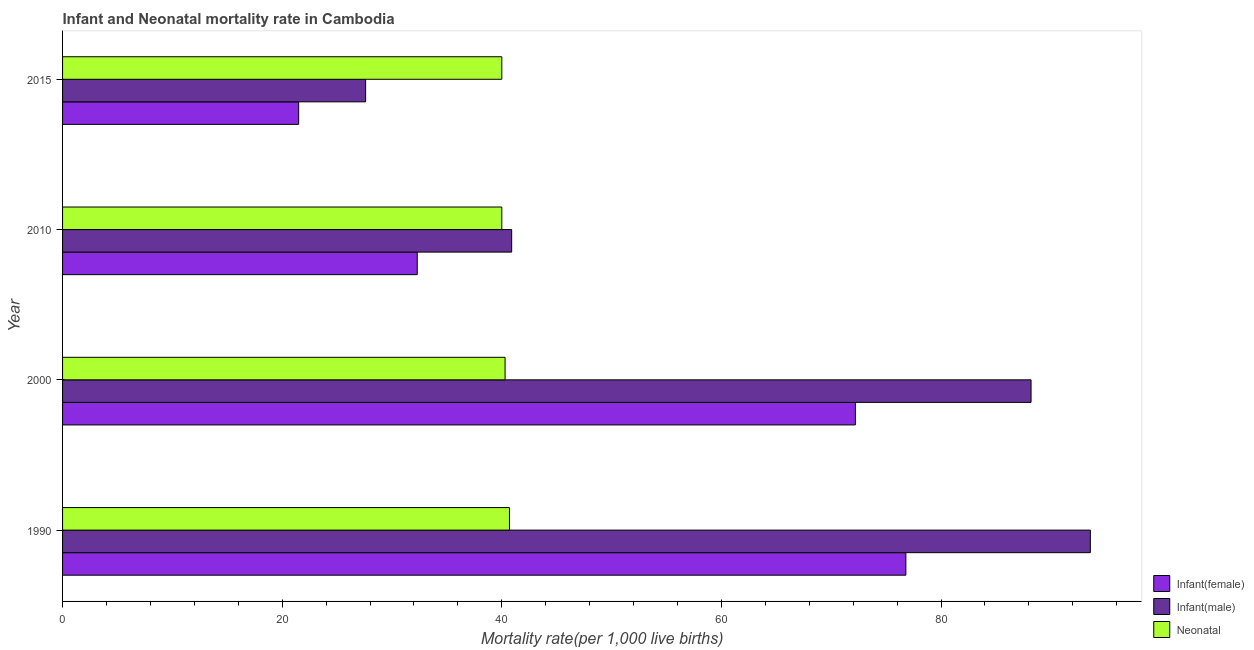What is the label of the 3rd group of bars from the top?
Your response must be concise. 2000. In how many cases, is the number of bars for a given year not equal to the number of legend labels?
Offer a very short reply. 0. What is the infant mortality rate(female) in 2015?
Give a very brief answer. 21.5. Across all years, what is the maximum infant mortality rate(female)?
Give a very brief answer. 76.8. Across all years, what is the minimum infant mortality rate(female)?
Give a very brief answer. 21.5. In which year was the infant mortality rate(female) minimum?
Your response must be concise. 2015. What is the total infant mortality rate(male) in the graph?
Provide a succinct answer. 250.3. What is the difference between the infant mortality rate(male) in 1990 and that in 2010?
Offer a very short reply. 52.7. What is the difference between the neonatal mortality rate in 2010 and the infant mortality rate(female) in 2015?
Your answer should be compact. 18.5. What is the average infant mortality rate(female) per year?
Your response must be concise. 50.7. In the year 2010, what is the difference between the neonatal mortality rate and infant mortality rate(female)?
Offer a terse response. 7.7. What is the ratio of the infant mortality rate(female) in 1990 to that in 2015?
Provide a short and direct response. 3.57. Is the infant mortality rate(female) in 2000 less than that in 2015?
Provide a succinct answer. No. What is the difference between the highest and the second highest neonatal mortality rate?
Provide a short and direct response. 0.4. What is the difference between the highest and the lowest infant mortality rate(male)?
Provide a short and direct response. 66. Is the sum of the infant mortality rate(female) in 2000 and 2010 greater than the maximum neonatal mortality rate across all years?
Make the answer very short. Yes. What does the 2nd bar from the top in 1990 represents?
Offer a very short reply. Infant(male). What does the 2nd bar from the bottom in 2015 represents?
Give a very brief answer. Infant(male). Is it the case that in every year, the sum of the infant mortality rate(female) and infant mortality rate(male) is greater than the neonatal mortality rate?
Make the answer very short. Yes. How many bars are there?
Offer a very short reply. 12. Are all the bars in the graph horizontal?
Your answer should be very brief. Yes. Are the values on the major ticks of X-axis written in scientific E-notation?
Provide a short and direct response. No. Does the graph contain any zero values?
Give a very brief answer. No. How many legend labels are there?
Offer a very short reply. 3. How are the legend labels stacked?
Give a very brief answer. Vertical. What is the title of the graph?
Your answer should be very brief. Infant and Neonatal mortality rate in Cambodia. Does "Argument" appear as one of the legend labels in the graph?
Make the answer very short. No. What is the label or title of the X-axis?
Your answer should be very brief. Mortality rate(per 1,0 live births). What is the label or title of the Y-axis?
Offer a very short reply. Year. What is the Mortality rate(per 1,000 live births) in Infant(female) in 1990?
Provide a succinct answer. 76.8. What is the Mortality rate(per 1,000 live births) of Infant(male) in 1990?
Offer a very short reply. 93.6. What is the Mortality rate(per 1,000 live births) in Neonatal  in 1990?
Make the answer very short. 40.7. What is the Mortality rate(per 1,000 live births) of Infant(female) in 2000?
Your answer should be very brief. 72.2. What is the Mortality rate(per 1,000 live births) in Infant(male) in 2000?
Offer a terse response. 88.2. What is the Mortality rate(per 1,000 live births) of Neonatal  in 2000?
Make the answer very short. 40.3. What is the Mortality rate(per 1,000 live births) of Infant(female) in 2010?
Your answer should be compact. 32.3. What is the Mortality rate(per 1,000 live births) in Infant(male) in 2010?
Your response must be concise. 40.9. What is the Mortality rate(per 1,000 live births) in Neonatal  in 2010?
Your answer should be very brief. 40. What is the Mortality rate(per 1,000 live births) of Infant(male) in 2015?
Keep it short and to the point. 27.6. What is the Mortality rate(per 1,000 live births) of Neonatal  in 2015?
Provide a short and direct response. 40. Across all years, what is the maximum Mortality rate(per 1,000 live births) in Infant(female)?
Provide a short and direct response. 76.8. Across all years, what is the maximum Mortality rate(per 1,000 live births) in Infant(male)?
Offer a very short reply. 93.6. Across all years, what is the maximum Mortality rate(per 1,000 live births) in Neonatal ?
Your answer should be very brief. 40.7. Across all years, what is the minimum Mortality rate(per 1,000 live births) of Infant(female)?
Make the answer very short. 21.5. Across all years, what is the minimum Mortality rate(per 1,000 live births) of Infant(male)?
Give a very brief answer. 27.6. Across all years, what is the minimum Mortality rate(per 1,000 live births) in Neonatal ?
Ensure brevity in your answer.  40. What is the total Mortality rate(per 1,000 live births) of Infant(female) in the graph?
Make the answer very short. 202.8. What is the total Mortality rate(per 1,000 live births) in Infant(male) in the graph?
Offer a very short reply. 250.3. What is the total Mortality rate(per 1,000 live births) in Neonatal  in the graph?
Give a very brief answer. 161. What is the difference between the Mortality rate(per 1,000 live births) of Infant(male) in 1990 and that in 2000?
Your answer should be compact. 5.4. What is the difference between the Mortality rate(per 1,000 live births) in Infant(female) in 1990 and that in 2010?
Your response must be concise. 44.5. What is the difference between the Mortality rate(per 1,000 live births) in Infant(male) in 1990 and that in 2010?
Ensure brevity in your answer.  52.7. What is the difference between the Mortality rate(per 1,000 live births) in Neonatal  in 1990 and that in 2010?
Provide a succinct answer. 0.7. What is the difference between the Mortality rate(per 1,000 live births) in Infant(female) in 1990 and that in 2015?
Provide a short and direct response. 55.3. What is the difference between the Mortality rate(per 1,000 live births) in Infant(female) in 2000 and that in 2010?
Make the answer very short. 39.9. What is the difference between the Mortality rate(per 1,000 live births) in Infant(male) in 2000 and that in 2010?
Your answer should be compact. 47.3. What is the difference between the Mortality rate(per 1,000 live births) in Neonatal  in 2000 and that in 2010?
Provide a succinct answer. 0.3. What is the difference between the Mortality rate(per 1,000 live births) of Infant(female) in 2000 and that in 2015?
Provide a succinct answer. 50.7. What is the difference between the Mortality rate(per 1,000 live births) in Infant(male) in 2000 and that in 2015?
Your response must be concise. 60.6. What is the difference between the Mortality rate(per 1,000 live births) of Infant(female) in 2010 and that in 2015?
Your answer should be very brief. 10.8. What is the difference between the Mortality rate(per 1,000 live births) of Infant(male) in 2010 and that in 2015?
Give a very brief answer. 13.3. What is the difference between the Mortality rate(per 1,000 live births) of Neonatal  in 2010 and that in 2015?
Provide a succinct answer. 0. What is the difference between the Mortality rate(per 1,000 live births) in Infant(female) in 1990 and the Mortality rate(per 1,000 live births) in Neonatal  in 2000?
Offer a very short reply. 36.5. What is the difference between the Mortality rate(per 1,000 live births) in Infant(male) in 1990 and the Mortality rate(per 1,000 live births) in Neonatal  in 2000?
Provide a short and direct response. 53.3. What is the difference between the Mortality rate(per 1,000 live births) in Infant(female) in 1990 and the Mortality rate(per 1,000 live births) in Infant(male) in 2010?
Your response must be concise. 35.9. What is the difference between the Mortality rate(per 1,000 live births) of Infant(female) in 1990 and the Mortality rate(per 1,000 live births) of Neonatal  in 2010?
Your response must be concise. 36.8. What is the difference between the Mortality rate(per 1,000 live births) in Infant(male) in 1990 and the Mortality rate(per 1,000 live births) in Neonatal  in 2010?
Provide a succinct answer. 53.6. What is the difference between the Mortality rate(per 1,000 live births) in Infant(female) in 1990 and the Mortality rate(per 1,000 live births) in Infant(male) in 2015?
Your response must be concise. 49.2. What is the difference between the Mortality rate(per 1,000 live births) in Infant(female) in 1990 and the Mortality rate(per 1,000 live births) in Neonatal  in 2015?
Your answer should be very brief. 36.8. What is the difference between the Mortality rate(per 1,000 live births) of Infant(male) in 1990 and the Mortality rate(per 1,000 live births) of Neonatal  in 2015?
Offer a very short reply. 53.6. What is the difference between the Mortality rate(per 1,000 live births) in Infant(female) in 2000 and the Mortality rate(per 1,000 live births) in Infant(male) in 2010?
Your response must be concise. 31.3. What is the difference between the Mortality rate(per 1,000 live births) of Infant(female) in 2000 and the Mortality rate(per 1,000 live births) of Neonatal  in 2010?
Offer a terse response. 32.2. What is the difference between the Mortality rate(per 1,000 live births) in Infant(male) in 2000 and the Mortality rate(per 1,000 live births) in Neonatal  in 2010?
Give a very brief answer. 48.2. What is the difference between the Mortality rate(per 1,000 live births) of Infant(female) in 2000 and the Mortality rate(per 1,000 live births) of Infant(male) in 2015?
Give a very brief answer. 44.6. What is the difference between the Mortality rate(per 1,000 live births) in Infant(female) in 2000 and the Mortality rate(per 1,000 live births) in Neonatal  in 2015?
Provide a short and direct response. 32.2. What is the difference between the Mortality rate(per 1,000 live births) in Infant(male) in 2000 and the Mortality rate(per 1,000 live births) in Neonatal  in 2015?
Offer a terse response. 48.2. What is the difference between the Mortality rate(per 1,000 live births) in Infant(female) in 2010 and the Mortality rate(per 1,000 live births) in Infant(male) in 2015?
Provide a succinct answer. 4.7. What is the difference between the Mortality rate(per 1,000 live births) of Infant(male) in 2010 and the Mortality rate(per 1,000 live births) of Neonatal  in 2015?
Your answer should be compact. 0.9. What is the average Mortality rate(per 1,000 live births) in Infant(female) per year?
Provide a short and direct response. 50.7. What is the average Mortality rate(per 1,000 live births) of Infant(male) per year?
Offer a very short reply. 62.58. What is the average Mortality rate(per 1,000 live births) in Neonatal  per year?
Your answer should be compact. 40.25. In the year 1990, what is the difference between the Mortality rate(per 1,000 live births) of Infant(female) and Mortality rate(per 1,000 live births) of Infant(male)?
Your answer should be compact. -16.8. In the year 1990, what is the difference between the Mortality rate(per 1,000 live births) of Infant(female) and Mortality rate(per 1,000 live births) of Neonatal ?
Your response must be concise. 36.1. In the year 1990, what is the difference between the Mortality rate(per 1,000 live births) in Infant(male) and Mortality rate(per 1,000 live births) in Neonatal ?
Make the answer very short. 52.9. In the year 2000, what is the difference between the Mortality rate(per 1,000 live births) in Infant(female) and Mortality rate(per 1,000 live births) in Infant(male)?
Give a very brief answer. -16. In the year 2000, what is the difference between the Mortality rate(per 1,000 live births) of Infant(female) and Mortality rate(per 1,000 live births) of Neonatal ?
Ensure brevity in your answer.  31.9. In the year 2000, what is the difference between the Mortality rate(per 1,000 live births) of Infant(male) and Mortality rate(per 1,000 live births) of Neonatal ?
Provide a short and direct response. 47.9. In the year 2010, what is the difference between the Mortality rate(per 1,000 live births) of Infant(female) and Mortality rate(per 1,000 live births) of Infant(male)?
Offer a very short reply. -8.6. In the year 2010, what is the difference between the Mortality rate(per 1,000 live births) in Infant(female) and Mortality rate(per 1,000 live births) in Neonatal ?
Make the answer very short. -7.7. In the year 2015, what is the difference between the Mortality rate(per 1,000 live births) in Infant(female) and Mortality rate(per 1,000 live births) in Infant(male)?
Your answer should be compact. -6.1. In the year 2015, what is the difference between the Mortality rate(per 1,000 live births) of Infant(female) and Mortality rate(per 1,000 live births) of Neonatal ?
Ensure brevity in your answer.  -18.5. What is the ratio of the Mortality rate(per 1,000 live births) of Infant(female) in 1990 to that in 2000?
Provide a succinct answer. 1.06. What is the ratio of the Mortality rate(per 1,000 live births) in Infant(male) in 1990 to that in 2000?
Offer a terse response. 1.06. What is the ratio of the Mortality rate(per 1,000 live births) of Neonatal  in 1990 to that in 2000?
Give a very brief answer. 1.01. What is the ratio of the Mortality rate(per 1,000 live births) in Infant(female) in 1990 to that in 2010?
Keep it short and to the point. 2.38. What is the ratio of the Mortality rate(per 1,000 live births) of Infant(male) in 1990 to that in 2010?
Your answer should be compact. 2.29. What is the ratio of the Mortality rate(per 1,000 live births) in Neonatal  in 1990 to that in 2010?
Make the answer very short. 1.02. What is the ratio of the Mortality rate(per 1,000 live births) in Infant(female) in 1990 to that in 2015?
Offer a very short reply. 3.57. What is the ratio of the Mortality rate(per 1,000 live births) of Infant(male) in 1990 to that in 2015?
Give a very brief answer. 3.39. What is the ratio of the Mortality rate(per 1,000 live births) in Neonatal  in 1990 to that in 2015?
Your answer should be very brief. 1.02. What is the ratio of the Mortality rate(per 1,000 live births) of Infant(female) in 2000 to that in 2010?
Your response must be concise. 2.24. What is the ratio of the Mortality rate(per 1,000 live births) in Infant(male) in 2000 to that in 2010?
Give a very brief answer. 2.16. What is the ratio of the Mortality rate(per 1,000 live births) in Neonatal  in 2000 to that in 2010?
Your answer should be very brief. 1.01. What is the ratio of the Mortality rate(per 1,000 live births) in Infant(female) in 2000 to that in 2015?
Your response must be concise. 3.36. What is the ratio of the Mortality rate(per 1,000 live births) in Infant(male) in 2000 to that in 2015?
Provide a short and direct response. 3.2. What is the ratio of the Mortality rate(per 1,000 live births) of Neonatal  in 2000 to that in 2015?
Your response must be concise. 1.01. What is the ratio of the Mortality rate(per 1,000 live births) in Infant(female) in 2010 to that in 2015?
Offer a terse response. 1.5. What is the ratio of the Mortality rate(per 1,000 live births) in Infant(male) in 2010 to that in 2015?
Make the answer very short. 1.48. What is the ratio of the Mortality rate(per 1,000 live births) in Neonatal  in 2010 to that in 2015?
Ensure brevity in your answer.  1. What is the difference between the highest and the second highest Mortality rate(per 1,000 live births) in Infant(female)?
Provide a short and direct response. 4.6. What is the difference between the highest and the second highest Mortality rate(per 1,000 live births) of Infant(male)?
Make the answer very short. 5.4. What is the difference between the highest and the lowest Mortality rate(per 1,000 live births) in Infant(female)?
Your answer should be very brief. 55.3. What is the difference between the highest and the lowest Mortality rate(per 1,000 live births) in Infant(male)?
Make the answer very short. 66. What is the difference between the highest and the lowest Mortality rate(per 1,000 live births) in Neonatal ?
Offer a very short reply. 0.7. 